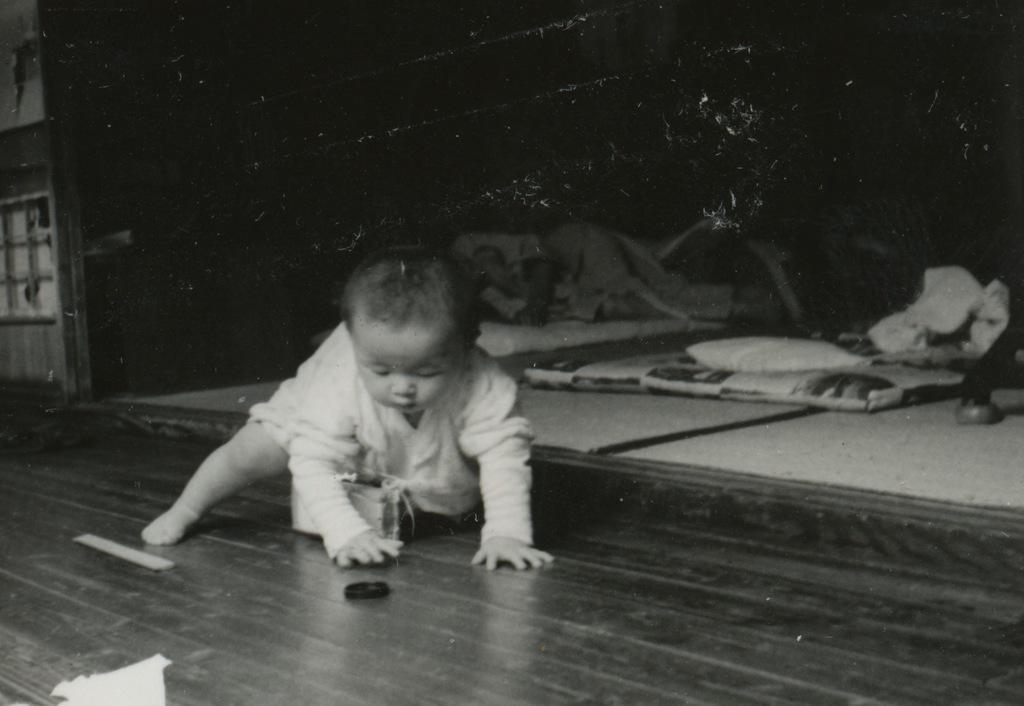Could you give a brief overview of what you see in this image? In the center of the image we can see baby crawling on the floor. In the background we can see person, pillows and wall. 